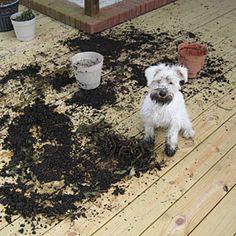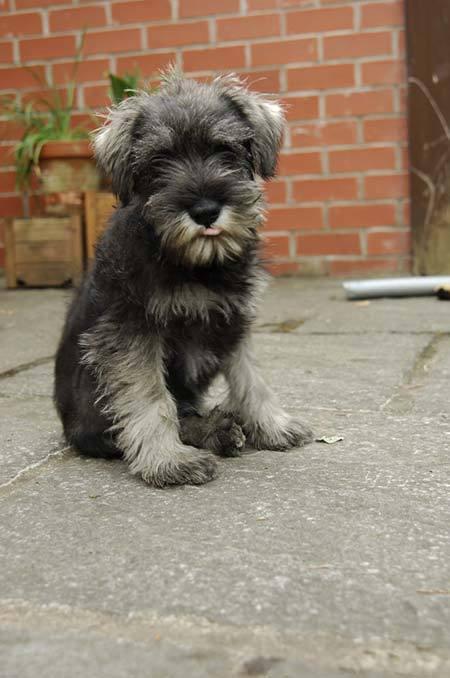The first image is the image on the left, the second image is the image on the right. For the images shown, is this caption "One of the dogs is next to a human, and at least one of the dogs is close to a couch." true? Answer yes or no. No. The first image is the image on the left, the second image is the image on the right. Evaluate the accuracy of this statement regarding the images: "Part of a human limb is visible in an image containing one small schnauzer dog.". Is it true? Answer yes or no. No. 